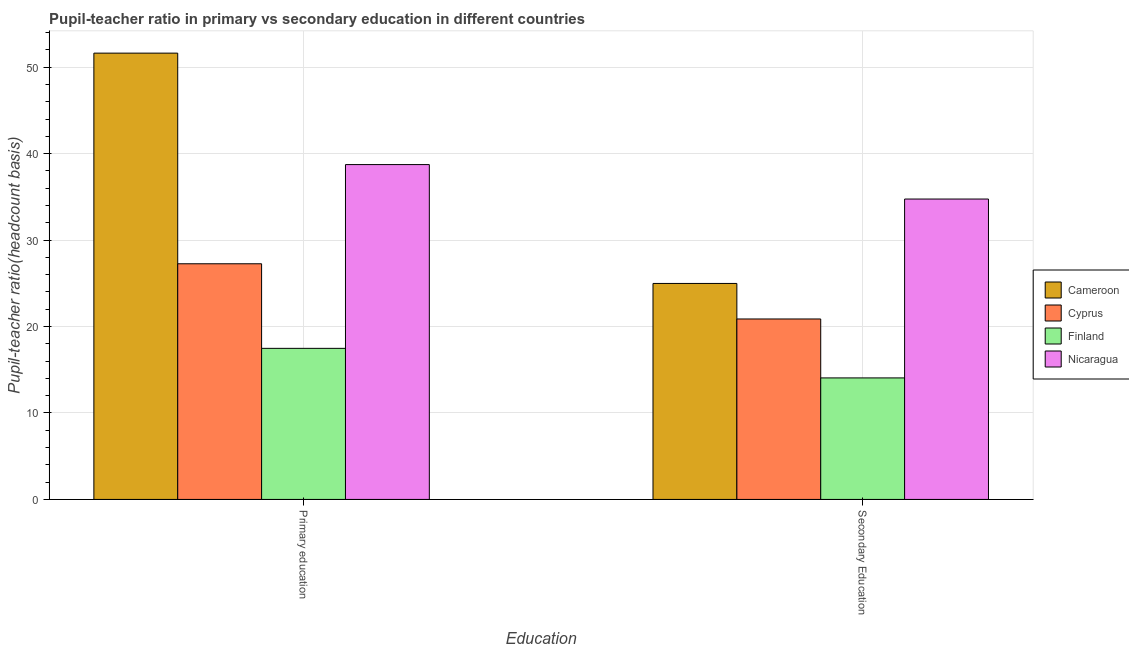Are the number of bars per tick equal to the number of legend labels?
Make the answer very short. Yes. Are the number of bars on each tick of the X-axis equal?
Provide a short and direct response. Yes. What is the pupil-teacher ratio in primary education in Cyprus?
Make the answer very short. 27.26. Across all countries, what is the maximum pupil-teacher ratio in primary education?
Offer a very short reply. 51.63. Across all countries, what is the minimum pupil-teacher ratio in primary education?
Your answer should be compact. 17.48. In which country was the pupil-teacher ratio in primary education maximum?
Your answer should be compact. Cameroon. In which country was the pupil teacher ratio on secondary education minimum?
Your answer should be very brief. Finland. What is the total pupil-teacher ratio in primary education in the graph?
Your answer should be very brief. 135.1. What is the difference between the pupil-teacher ratio in primary education in Cameroon and that in Cyprus?
Make the answer very short. 24.37. What is the difference between the pupil teacher ratio on secondary education in Nicaragua and the pupil-teacher ratio in primary education in Cameroon?
Make the answer very short. -16.88. What is the average pupil teacher ratio on secondary education per country?
Give a very brief answer. 23.67. What is the difference between the pupil teacher ratio on secondary education and pupil-teacher ratio in primary education in Nicaragua?
Ensure brevity in your answer.  -3.99. What is the ratio of the pupil teacher ratio on secondary education in Cameroon to that in Finland?
Ensure brevity in your answer.  1.78. Is the pupil teacher ratio on secondary education in Cameroon less than that in Cyprus?
Keep it short and to the point. No. In how many countries, is the pupil-teacher ratio in primary education greater than the average pupil-teacher ratio in primary education taken over all countries?
Provide a succinct answer. 2. What does the 2nd bar from the left in Secondary Education represents?
Offer a very short reply. Cyprus. What does the 3rd bar from the right in Secondary Education represents?
Provide a succinct answer. Cyprus. Are all the bars in the graph horizontal?
Your answer should be compact. No. How many countries are there in the graph?
Your answer should be compact. 4. What is the difference between two consecutive major ticks on the Y-axis?
Make the answer very short. 10. How many legend labels are there?
Provide a succinct answer. 4. What is the title of the graph?
Your response must be concise. Pupil-teacher ratio in primary vs secondary education in different countries. Does "Morocco" appear as one of the legend labels in the graph?
Your answer should be very brief. No. What is the label or title of the X-axis?
Keep it short and to the point. Education. What is the label or title of the Y-axis?
Make the answer very short. Pupil-teacher ratio(headcount basis). What is the Pupil-teacher ratio(headcount basis) in Cameroon in Primary education?
Ensure brevity in your answer.  51.63. What is the Pupil-teacher ratio(headcount basis) in Cyprus in Primary education?
Your response must be concise. 27.26. What is the Pupil-teacher ratio(headcount basis) of Finland in Primary education?
Ensure brevity in your answer.  17.48. What is the Pupil-teacher ratio(headcount basis) in Nicaragua in Primary education?
Provide a short and direct response. 38.74. What is the Pupil-teacher ratio(headcount basis) of Cameroon in Secondary Education?
Provide a short and direct response. 24.99. What is the Pupil-teacher ratio(headcount basis) of Cyprus in Secondary Education?
Make the answer very short. 20.87. What is the Pupil-teacher ratio(headcount basis) of Finland in Secondary Education?
Give a very brief answer. 14.06. What is the Pupil-teacher ratio(headcount basis) in Nicaragua in Secondary Education?
Offer a terse response. 34.75. Across all Education, what is the maximum Pupil-teacher ratio(headcount basis) in Cameroon?
Your answer should be compact. 51.63. Across all Education, what is the maximum Pupil-teacher ratio(headcount basis) in Cyprus?
Offer a terse response. 27.26. Across all Education, what is the maximum Pupil-teacher ratio(headcount basis) in Finland?
Your answer should be compact. 17.48. Across all Education, what is the maximum Pupil-teacher ratio(headcount basis) of Nicaragua?
Make the answer very short. 38.74. Across all Education, what is the minimum Pupil-teacher ratio(headcount basis) in Cameroon?
Ensure brevity in your answer.  24.99. Across all Education, what is the minimum Pupil-teacher ratio(headcount basis) in Cyprus?
Offer a very short reply. 20.87. Across all Education, what is the minimum Pupil-teacher ratio(headcount basis) of Finland?
Give a very brief answer. 14.06. Across all Education, what is the minimum Pupil-teacher ratio(headcount basis) of Nicaragua?
Offer a terse response. 34.75. What is the total Pupil-teacher ratio(headcount basis) in Cameroon in the graph?
Your response must be concise. 76.61. What is the total Pupil-teacher ratio(headcount basis) in Cyprus in the graph?
Your response must be concise. 48.14. What is the total Pupil-teacher ratio(headcount basis) in Finland in the graph?
Provide a short and direct response. 31.53. What is the total Pupil-teacher ratio(headcount basis) of Nicaragua in the graph?
Offer a very short reply. 73.49. What is the difference between the Pupil-teacher ratio(headcount basis) of Cameroon in Primary education and that in Secondary Education?
Your response must be concise. 26.64. What is the difference between the Pupil-teacher ratio(headcount basis) of Cyprus in Primary education and that in Secondary Education?
Offer a terse response. 6.39. What is the difference between the Pupil-teacher ratio(headcount basis) of Finland in Primary education and that in Secondary Education?
Your answer should be very brief. 3.42. What is the difference between the Pupil-teacher ratio(headcount basis) in Nicaragua in Primary education and that in Secondary Education?
Your response must be concise. 3.99. What is the difference between the Pupil-teacher ratio(headcount basis) in Cameroon in Primary education and the Pupil-teacher ratio(headcount basis) in Cyprus in Secondary Education?
Make the answer very short. 30.75. What is the difference between the Pupil-teacher ratio(headcount basis) in Cameroon in Primary education and the Pupil-teacher ratio(headcount basis) in Finland in Secondary Education?
Make the answer very short. 37.57. What is the difference between the Pupil-teacher ratio(headcount basis) in Cameroon in Primary education and the Pupil-teacher ratio(headcount basis) in Nicaragua in Secondary Education?
Offer a terse response. 16.88. What is the difference between the Pupil-teacher ratio(headcount basis) in Cyprus in Primary education and the Pupil-teacher ratio(headcount basis) in Finland in Secondary Education?
Ensure brevity in your answer.  13.2. What is the difference between the Pupil-teacher ratio(headcount basis) of Cyprus in Primary education and the Pupil-teacher ratio(headcount basis) of Nicaragua in Secondary Education?
Your response must be concise. -7.49. What is the difference between the Pupil-teacher ratio(headcount basis) of Finland in Primary education and the Pupil-teacher ratio(headcount basis) of Nicaragua in Secondary Education?
Offer a very short reply. -17.27. What is the average Pupil-teacher ratio(headcount basis) in Cameroon per Education?
Keep it short and to the point. 38.31. What is the average Pupil-teacher ratio(headcount basis) in Cyprus per Education?
Keep it short and to the point. 24.07. What is the average Pupil-teacher ratio(headcount basis) of Finland per Education?
Give a very brief answer. 15.77. What is the average Pupil-teacher ratio(headcount basis) of Nicaragua per Education?
Your answer should be compact. 36.74. What is the difference between the Pupil-teacher ratio(headcount basis) in Cameroon and Pupil-teacher ratio(headcount basis) in Cyprus in Primary education?
Provide a succinct answer. 24.37. What is the difference between the Pupil-teacher ratio(headcount basis) in Cameroon and Pupil-teacher ratio(headcount basis) in Finland in Primary education?
Provide a succinct answer. 34.15. What is the difference between the Pupil-teacher ratio(headcount basis) of Cameroon and Pupil-teacher ratio(headcount basis) of Nicaragua in Primary education?
Your response must be concise. 12.89. What is the difference between the Pupil-teacher ratio(headcount basis) of Cyprus and Pupil-teacher ratio(headcount basis) of Finland in Primary education?
Provide a short and direct response. 9.79. What is the difference between the Pupil-teacher ratio(headcount basis) in Cyprus and Pupil-teacher ratio(headcount basis) in Nicaragua in Primary education?
Keep it short and to the point. -11.47. What is the difference between the Pupil-teacher ratio(headcount basis) in Finland and Pupil-teacher ratio(headcount basis) in Nicaragua in Primary education?
Your answer should be compact. -21.26. What is the difference between the Pupil-teacher ratio(headcount basis) of Cameroon and Pupil-teacher ratio(headcount basis) of Cyprus in Secondary Education?
Provide a short and direct response. 4.11. What is the difference between the Pupil-teacher ratio(headcount basis) of Cameroon and Pupil-teacher ratio(headcount basis) of Finland in Secondary Education?
Give a very brief answer. 10.93. What is the difference between the Pupil-teacher ratio(headcount basis) of Cameroon and Pupil-teacher ratio(headcount basis) of Nicaragua in Secondary Education?
Offer a very short reply. -9.76. What is the difference between the Pupil-teacher ratio(headcount basis) in Cyprus and Pupil-teacher ratio(headcount basis) in Finland in Secondary Education?
Offer a very short reply. 6.82. What is the difference between the Pupil-teacher ratio(headcount basis) in Cyprus and Pupil-teacher ratio(headcount basis) in Nicaragua in Secondary Education?
Your response must be concise. -13.88. What is the difference between the Pupil-teacher ratio(headcount basis) of Finland and Pupil-teacher ratio(headcount basis) of Nicaragua in Secondary Education?
Your answer should be very brief. -20.69. What is the ratio of the Pupil-teacher ratio(headcount basis) of Cameroon in Primary education to that in Secondary Education?
Provide a succinct answer. 2.07. What is the ratio of the Pupil-teacher ratio(headcount basis) in Cyprus in Primary education to that in Secondary Education?
Ensure brevity in your answer.  1.31. What is the ratio of the Pupil-teacher ratio(headcount basis) in Finland in Primary education to that in Secondary Education?
Ensure brevity in your answer.  1.24. What is the ratio of the Pupil-teacher ratio(headcount basis) of Nicaragua in Primary education to that in Secondary Education?
Offer a terse response. 1.11. What is the difference between the highest and the second highest Pupil-teacher ratio(headcount basis) of Cameroon?
Give a very brief answer. 26.64. What is the difference between the highest and the second highest Pupil-teacher ratio(headcount basis) of Cyprus?
Offer a very short reply. 6.39. What is the difference between the highest and the second highest Pupil-teacher ratio(headcount basis) of Finland?
Provide a short and direct response. 3.42. What is the difference between the highest and the second highest Pupil-teacher ratio(headcount basis) in Nicaragua?
Your answer should be very brief. 3.99. What is the difference between the highest and the lowest Pupil-teacher ratio(headcount basis) in Cameroon?
Provide a succinct answer. 26.64. What is the difference between the highest and the lowest Pupil-teacher ratio(headcount basis) of Cyprus?
Provide a succinct answer. 6.39. What is the difference between the highest and the lowest Pupil-teacher ratio(headcount basis) of Finland?
Your answer should be compact. 3.42. What is the difference between the highest and the lowest Pupil-teacher ratio(headcount basis) of Nicaragua?
Provide a succinct answer. 3.99. 